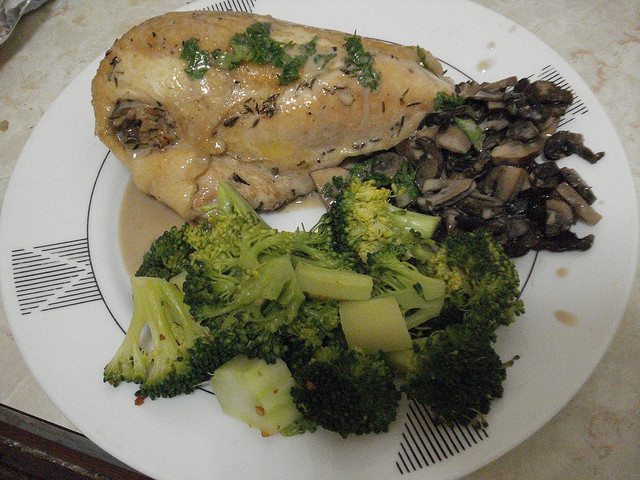Describe the objects in this image and their specific colors. I can see broccoli in gray, black, and olive tones and dining table in gray, darkgray, and tan tones in this image. 